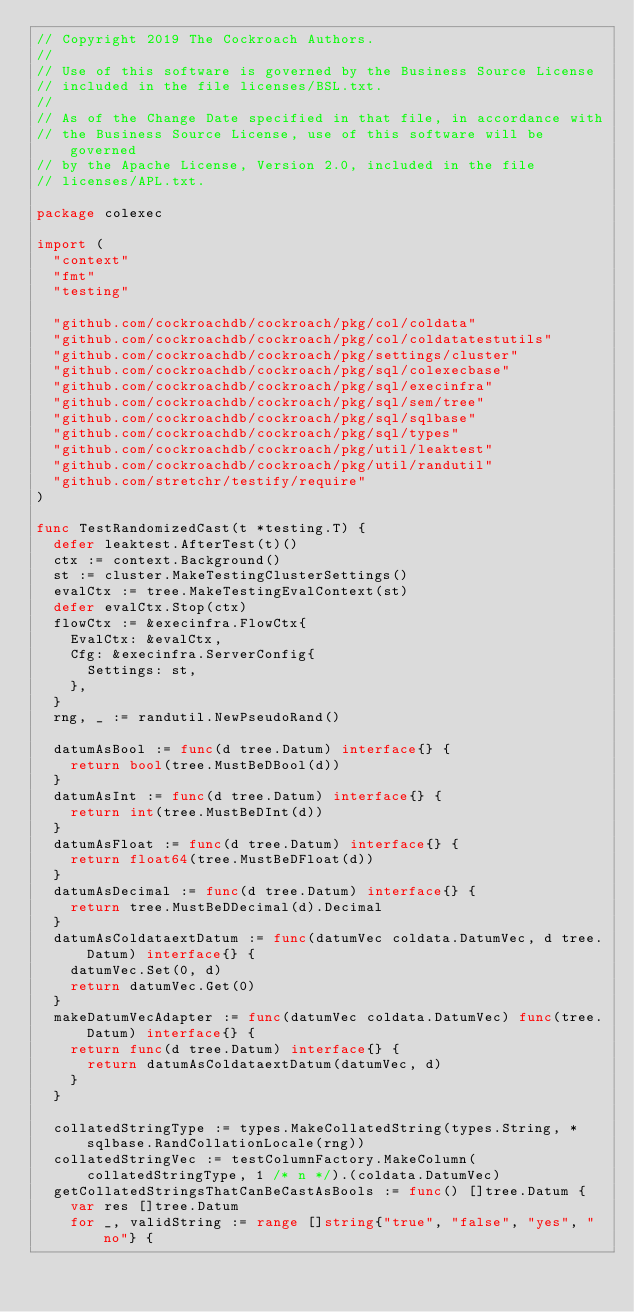<code> <loc_0><loc_0><loc_500><loc_500><_Go_>// Copyright 2019 The Cockroach Authors.
//
// Use of this software is governed by the Business Source License
// included in the file licenses/BSL.txt.
//
// As of the Change Date specified in that file, in accordance with
// the Business Source License, use of this software will be governed
// by the Apache License, Version 2.0, included in the file
// licenses/APL.txt.

package colexec

import (
	"context"
	"fmt"
	"testing"

	"github.com/cockroachdb/cockroach/pkg/col/coldata"
	"github.com/cockroachdb/cockroach/pkg/col/coldatatestutils"
	"github.com/cockroachdb/cockroach/pkg/settings/cluster"
	"github.com/cockroachdb/cockroach/pkg/sql/colexecbase"
	"github.com/cockroachdb/cockroach/pkg/sql/execinfra"
	"github.com/cockroachdb/cockroach/pkg/sql/sem/tree"
	"github.com/cockroachdb/cockroach/pkg/sql/sqlbase"
	"github.com/cockroachdb/cockroach/pkg/sql/types"
	"github.com/cockroachdb/cockroach/pkg/util/leaktest"
	"github.com/cockroachdb/cockroach/pkg/util/randutil"
	"github.com/stretchr/testify/require"
)

func TestRandomizedCast(t *testing.T) {
	defer leaktest.AfterTest(t)()
	ctx := context.Background()
	st := cluster.MakeTestingClusterSettings()
	evalCtx := tree.MakeTestingEvalContext(st)
	defer evalCtx.Stop(ctx)
	flowCtx := &execinfra.FlowCtx{
		EvalCtx: &evalCtx,
		Cfg: &execinfra.ServerConfig{
			Settings: st,
		},
	}
	rng, _ := randutil.NewPseudoRand()

	datumAsBool := func(d tree.Datum) interface{} {
		return bool(tree.MustBeDBool(d))
	}
	datumAsInt := func(d tree.Datum) interface{} {
		return int(tree.MustBeDInt(d))
	}
	datumAsFloat := func(d tree.Datum) interface{} {
		return float64(tree.MustBeDFloat(d))
	}
	datumAsDecimal := func(d tree.Datum) interface{} {
		return tree.MustBeDDecimal(d).Decimal
	}
	datumAsColdataextDatum := func(datumVec coldata.DatumVec, d tree.Datum) interface{} {
		datumVec.Set(0, d)
		return datumVec.Get(0)
	}
	makeDatumVecAdapter := func(datumVec coldata.DatumVec) func(tree.Datum) interface{} {
		return func(d tree.Datum) interface{} {
			return datumAsColdataextDatum(datumVec, d)
		}
	}

	collatedStringType := types.MakeCollatedString(types.String, *sqlbase.RandCollationLocale(rng))
	collatedStringVec := testColumnFactory.MakeColumn(collatedStringType, 1 /* n */).(coldata.DatumVec)
	getCollatedStringsThatCanBeCastAsBools := func() []tree.Datum {
		var res []tree.Datum
		for _, validString := range []string{"true", "false", "yes", "no"} {</code> 